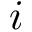Convert formula to latex. <formula><loc_0><loc_0><loc_500><loc_500>i</formula> 